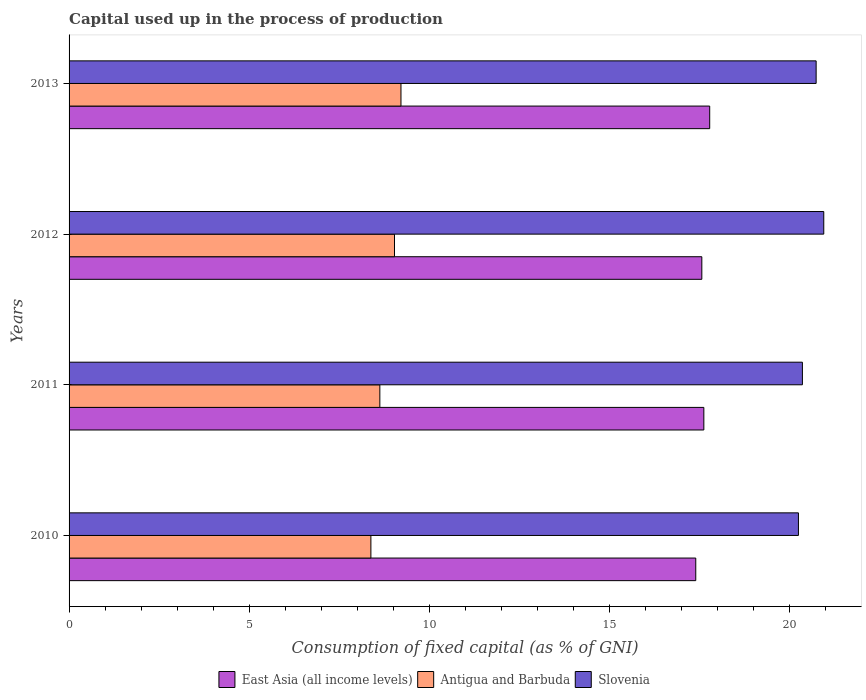How many groups of bars are there?
Provide a short and direct response. 4. How many bars are there on the 2nd tick from the top?
Give a very brief answer. 3. How many bars are there on the 4th tick from the bottom?
Keep it short and to the point. 3. In how many cases, is the number of bars for a given year not equal to the number of legend labels?
Offer a terse response. 0. What is the capital used up in the process of production in East Asia (all income levels) in 2010?
Keep it short and to the point. 17.4. Across all years, what is the maximum capital used up in the process of production in East Asia (all income levels)?
Your answer should be very brief. 17.78. Across all years, what is the minimum capital used up in the process of production in Antigua and Barbuda?
Give a very brief answer. 8.38. What is the total capital used up in the process of production in Antigua and Barbuda in the graph?
Provide a short and direct response. 35.25. What is the difference between the capital used up in the process of production in East Asia (all income levels) in 2010 and that in 2012?
Keep it short and to the point. -0.17. What is the difference between the capital used up in the process of production in Antigua and Barbuda in 2010 and the capital used up in the process of production in Slovenia in 2012?
Your answer should be compact. -12.57. What is the average capital used up in the process of production in Slovenia per year?
Your response must be concise. 20.57. In the year 2012, what is the difference between the capital used up in the process of production in Antigua and Barbuda and capital used up in the process of production in East Asia (all income levels)?
Offer a very short reply. -8.53. What is the ratio of the capital used up in the process of production in Slovenia in 2011 to that in 2012?
Offer a very short reply. 0.97. What is the difference between the highest and the second highest capital used up in the process of production in East Asia (all income levels)?
Provide a succinct answer. 0.16. What is the difference between the highest and the lowest capital used up in the process of production in Antigua and Barbuda?
Keep it short and to the point. 0.83. In how many years, is the capital used up in the process of production in East Asia (all income levels) greater than the average capital used up in the process of production in East Asia (all income levels) taken over all years?
Your response must be concise. 2. What does the 1st bar from the top in 2010 represents?
Give a very brief answer. Slovenia. What does the 3rd bar from the bottom in 2012 represents?
Provide a succinct answer. Slovenia. Are all the bars in the graph horizontal?
Your answer should be compact. Yes. How many years are there in the graph?
Offer a terse response. 4. Does the graph contain any zero values?
Provide a short and direct response. No. Where does the legend appear in the graph?
Provide a succinct answer. Bottom center. How are the legend labels stacked?
Make the answer very short. Horizontal. What is the title of the graph?
Give a very brief answer. Capital used up in the process of production. What is the label or title of the X-axis?
Offer a very short reply. Consumption of fixed capital (as % of GNI). What is the Consumption of fixed capital (as % of GNI) of East Asia (all income levels) in 2010?
Your answer should be very brief. 17.4. What is the Consumption of fixed capital (as % of GNI) in Antigua and Barbuda in 2010?
Your answer should be compact. 8.38. What is the Consumption of fixed capital (as % of GNI) of Slovenia in 2010?
Your response must be concise. 20.25. What is the Consumption of fixed capital (as % of GNI) of East Asia (all income levels) in 2011?
Ensure brevity in your answer.  17.62. What is the Consumption of fixed capital (as % of GNI) of Antigua and Barbuda in 2011?
Your response must be concise. 8.63. What is the Consumption of fixed capital (as % of GNI) in Slovenia in 2011?
Offer a very short reply. 20.36. What is the Consumption of fixed capital (as % of GNI) of East Asia (all income levels) in 2012?
Make the answer very short. 17.57. What is the Consumption of fixed capital (as % of GNI) of Antigua and Barbuda in 2012?
Provide a succinct answer. 9.03. What is the Consumption of fixed capital (as % of GNI) of Slovenia in 2012?
Provide a succinct answer. 20.95. What is the Consumption of fixed capital (as % of GNI) in East Asia (all income levels) in 2013?
Your answer should be compact. 17.78. What is the Consumption of fixed capital (as % of GNI) of Antigua and Barbuda in 2013?
Provide a short and direct response. 9.21. What is the Consumption of fixed capital (as % of GNI) in Slovenia in 2013?
Provide a succinct answer. 20.74. Across all years, what is the maximum Consumption of fixed capital (as % of GNI) in East Asia (all income levels)?
Offer a terse response. 17.78. Across all years, what is the maximum Consumption of fixed capital (as % of GNI) in Antigua and Barbuda?
Your answer should be compact. 9.21. Across all years, what is the maximum Consumption of fixed capital (as % of GNI) in Slovenia?
Ensure brevity in your answer.  20.95. Across all years, what is the minimum Consumption of fixed capital (as % of GNI) in East Asia (all income levels)?
Provide a succinct answer. 17.4. Across all years, what is the minimum Consumption of fixed capital (as % of GNI) in Antigua and Barbuda?
Offer a terse response. 8.38. Across all years, what is the minimum Consumption of fixed capital (as % of GNI) in Slovenia?
Keep it short and to the point. 20.25. What is the total Consumption of fixed capital (as % of GNI) in East Asia (all income levels) in the graph?
Give a very brief answer. 70.37. What is the total Consumption of fixed capital (as % of GNI) in Antigua and Barbuda in the graph?
Offer a terse response. 35.25. What is the total Consumption of fixed capital (as % of GNI) in Slovenia in the graph?
Ensure brevity in your answer.  82.3. What is the difference between the Consumption of fixed capital (as % of GNI) in East Asia (all income levels) in 2010 and that in 2011?
Your answer should be compact. -0.22. What is the difference between the Consumption of fixed capital (as % of GNI) of Antigua and Barbuda in 2010 and that in 2011?
Your response must be concise. -0.25. What is the difference between the Consumption of fixed capital (as % of GNI) in Slovenia in 2010 and that in 2011?
Make the answer very short. -0.11. What is the difference between the Consumption of fixed capital (as % of GNI) in East Asia (all income levels) in 2010 and that in 2012?
Make the answer very short. -0.17. What is the difference between the Consumption of fixed capital (as % of GNI) of Antigua and Barbuda in 2010 and that in 2012?
Offer a very short reply. -0.66. What is the difference between the Consumption of fixed capital (as % of GNI) in Slovenia in 2010 and that in 2012?
Give a very brief answer. -0.7. What is the difference between the Consumption of fixed capital (as % of GNI) of East Asia (all income levels) in 2010 and that in 2013?
Provide a succinct answer. -0.39. What is the difference between the Consumption of fixed capital (as % of GNI) of Antigua and Barbuda in 2010 and that in 2013?
Keep it short and to the point. -0.83. What is the difference between the Consumption of fixed capital (as % of GNI) of Slovenia in 2010 and that in 2013?
Provide a short and direct response. -0.49. What is the difference between the Consumption of fixed capital (as % of GNI) in East Asia (all income levels) in 2011 and that in 2012?
Provide a short and direct response. 0.06. What is the difference between the Consumption of fixed capital (as % of GNI) of Antigua and Barbuda in 2011 and that in 2012?
Keep it short and to the point. -0.41. What is the difference between the Consumption of fixed capital (as % of GNI) of Slovenia in 2011 and that in 2012?
Offer a very short reply. -0.59. What is the difference between the Consumption of fixed capital (as % of GNI) in East Asia (all income levels) in 2011 and that in 2013?
Make the answer very short. -0.16. What is the difference between the Consumption of fixed capital (as % of GNI) in Antigua and Barbuda in 2011 and that in 2013?
Make the answer very short. -0.59. What is the difference between the Consumption of fixed capital (as % of GNI) in Slovenia in 2011 and that in 2013?
Make the answer very short. -0.38. What is the difference between the Consumption of fixed capital (as % of GNI) of East Asia (all income levels) in 2012 and that in 2013?
Your answer should be compact. -0.22. What is the difference between the Consumption of fixed capital (as % of GNI) in Antigua and Barbuda in 2012 and that in 2013?
Provide a succinct answer. -0.18. What is the difference between the Consumption of fixed capital (as % of GNI) of Slovenia in 2012 and that in 2013?
Your answer should be compact. 0.21. What is the difference between the Consumption of fixed capital (as % of GNI) of East Asia (all income levels) in 2010 and the Consumption of fixed capital (as % of GNI) of Antigua and Barbuda in 2011?
Your answer should be compact. 8.77. What is the difference between the Consumption of fixed capital (as % of GNI) of East Asia (all income levels) in 2010 and the Consumption of fixed capital (as % of GNI) of Slovenia in 2011?
Provide a succinct answer. -2.96. What is the difference between the Consumption of fixed capital (as % of GNI) of Antigua and Barbuda in 2010 and the Consumption of fixed capital (as % of GNI) of Slovenia in 2011?
Provide a succinct answer. -11.98. What is the difference between the Consumption of fixed capital (as % of GNI) in East Asia (all income levels) in 2010 and the Consumption of fixed capital (as % of GNI) in Antigua and Barbuda in 2012?
Offer a terse response. 8.36. What is the difference between the Consumption of fixed capital (as % of GNI) in East Asia (all income levels) in 2010 and the Consumption of fixed capital (as % of GNI) in Slovenia in 2012?
Offer a terse response. -3.55. What is the difference between the Consumption of fixed capital (as % of GNI) of Antigua and Barbuda in 2010 and the Consumption of fixed capital (as % of GNI) of Slovenia in 2012?
Offer a terse response. -12.57. What is the difference between the Consumption of fixed capital (as % of GNI) in East Asia (all income levels) in 2010 and the Consumption of fixed capital (as % of GNI) in Antigua and Barbuda in 2013?
Keep it short and to the point. 8.18. What is the difference between the Consumption of fixed capital (as % of GNI) in East Asia (all income levels) in 2010 and the Consumption of fixed capital (as % of GNI) in Slovenia in 2013?
Give a very brief answer. -3.34. What is the difference between the Consumption of fixed capital (as % of GNI) of Antigua and Barbuda in 2010 and the Consumption of fixed capital (as % of GNI) of Slovenia in 2013?
Offer a terse response. -12.36. What is the difference between the Consumption of fixed capital (as % of GNI) in East Asia (all income levels) in 2011 and the Consumption of fixed capital (as % of GNI) in Antigua and Barbuda in 2012?
Your answer should be very brief. 8.59. What is the difference between the Consumption of fixed capital (as % of GNI) in East Asia (all income levels) in 2011 and the Consumption of fixed capital (as % of GNI) in Slovenia in 2012?
Ensure brevity in your answer.  -3.33. What is the difference between the Consumption of fixed capital (as % of GNI) of Antigua and Barbuda in 2011 and the Consumption of fixed capital (as % of GNI) of Slovenia in 2012?
Provide a succinct answer. -12.32. What is the difference between the Consumption of fixed capital (as % of GNI) in East Asia (all income levels) in 2011 and the Consumption of fixed capital (as % of GNI) in Antigua and Barbuda in 2013?
Give a very brief answer. 8.41. What is the difference between the Consumption of fixed capital (as % of GNI) in East Asia (all income levels) in 2011 and the Consumption of fixed capital (as % of GNI) in Slovenia in 2013?
Make the answer very short. -3.12. What is the difference between the Consumption of fixed capital (as % of GNI) of Antigua and Barbuda in 2011 and the Consumption of fixed capital (as % of GNI) of Slovenia in 2013?
Your response must be concise. -12.11. What is the difference between the Consumption of fixed capital (as % of GNI) of East Asia (all income levels) in 2012 and the Consumption of fixed capital (as % of GNI) of Antigua and Barbuda in 2013?
Your answer should be compact. 8.35. What is the difference between the Consumption of fixed capital (as % of GNI) of East Asia (all income levels) in 2012 and the Consumption of fixed capital (as % of GNI) of Slovenia in 2013?
Ensure brevity in your answer.  -3.17. What is the difference between the Consumption of fixed capital (as % of GNI) of Antigua and Barbuda in 2012 and the Consumption of fixed capital (as % of GNI) of Slovenia in 2013?
Give a very brief answer. -11.71. What is the average Consumption of fixed capital (as % of GNI) in East Asia (all income levels) per year?
Keep it short and to the point. 17.59. What is the average Consumption of fixed capital (as % of GNI) in Antigua and Barbuda per year?
Your response must be concise. 8.81. What is the average Consumption of fixed capital (as % of GNI) in Slovenia per year?
Keep it short and to the point. 20.57. In the year 2010, what is the difference between the Consumption of fixed capital (as % of GNI) in East Asia (all income levels) and Consumption of fixed capital (as % of GNI) in Antigua and Barbuda?
Ensure brevity in your answer.  9.02. In the year 2010, what is the difference between the Consumption of fixed capital (as % of GNI) of East Asia (all income levels) and Consumption of fixed capital (as % of GNI) of Slovenia?
Give a very brief answer. -2.85. In the year 2010, what is the difference between the Consumption of fixed capital (as % of GNI) in Antigua and Barbuda and Consumption of fixed capital (as % of GNI) in Slovenia?
Make the answer very short. -11.87. In the year 2011, what is the difference between the Consumption of fixed capital (as % of GNI) of East Asia (all income levels) and Consumption of fixed capital (as % of GNI) of Antigua and Barbuda?
Offer a terse response. 8.99. In the year 2011, what is the difference between the Consumption of fixed capital (as % of GNI) in East Asia (all income levels) and Consumption of fixed capital (as % of GNI) in Slovenia?
Your answer should be very brief. -2.74. In the year 2011, what is the difference between the Consumption of fixed capital (as % of GNI) of Antigua and Barbuda and Consumption of fixed capital (as % of GNI) of Slovenia?
Your response must be concise. -11.73. In the year 2012, what is the difference between the Consumption of fixed capital (as % of GNI) of East Asia (all income levels) and Consumption of fixed capital (as % of GNI) of Antigua and Barbuda?
Your response must be concise. 8.53. In the year 2012, what is the difference between the Consumption of fixed capital (as % of GNI) in East Asia (all income levels) and Consumption of fixed capital (as % of GNI) in Slovenia?
Your response must be concise. -3.38. In the year 2012, what is the difference between the Consumption of fixed capital (as % of GNI) of Antigua and Barbuda and Consumption of fixed capital (as % of GNI) of Slovenia?
Make the answer very short. -11.92. In the year 2013, what is the difference between the Consumption of fixed capital (as % of GNI) in East Asia (all income levels) and Consumption of fixed capital (as % of GNI) in Antigua and Barbuda?
Keep it short and to the point. 8.57. In the year 2013, what is the difference between the Consumption of fixed capital (as % of GNI) of East Asia (all income levels) and Consumption of fixed capital (as % of GNI) of Slovenia?
Your response must be concise. -2.95. In the year 2013, what is the difference between the Consumption of fixed capital (as % of GNI) of Antigua and Barbuda and Consumption of fixed capital (as % of GNI) of Slovenia?
Provide a succinct answer. -11.53. What is the ratio of the Consumption of fixed capital (as % of GNI) in East Asia (all income levels) in 2010 to that in 2011?
Your answer should be very brief. 0.99. What is the ratio of the Consumption of fixed capital (as % of GNI) in Antigua and Barbuda in 2010 to that in 2011?
Your answer should be very brief. 0.97. What is the ratio of the Consumption of fixed capital (as % of GNI) in Antigua and Barbuda in 2010 to that in 2012?
Provide a short and direct response. 0.93. What is the ratio of the Consumption of fixed capital (as % of GNI) of Slovenia in 2010 to that in 2012?
Provide a succinct answer. 0.97. What is the ratio of the Consumption of fixed capital (as % of GNI) in East Asia (all income levels) in 2010 to that in 2013?
Give a very brief answer. 0.98. What is the ratio of the Consumption of fixed capital (as % of GNI) in Antigua and Barbuda in 2010 to that in 2013?
Your response must be concise. 0.91. What is the ratio of the Consumption of fixed capital (as % of GNI) in Slovenia in 2010 to that in 2013?
Ensure brevity in your answer.  0.98. What is the ratio of the Consumption of fixed capital (as % of GNI) of East Asia (all income levels) in 2011 to that in 2012?
Provide a succinct answer. 1. What is the ratio of the Consumption of fixed capital (as % of GNI) in Antigua and Barbuda in 2011 to that in 2012?
Offer a very short reply. 0.95. What is the ratio of the Consumption of fixed capital (as % of GNI) in Slovenia in 2011 to that in 2012?
Make the answer very short. 0.97. What is the ratio of the Consumption of fixed capital (as % of GNI) of East Asia (all income levels) in 2011 to that in 2013?
Give a very brief answer. 0.99. What is the ratio of the Consumption of fixed capital (as % of GNI) of Antigua and Barbuda in 2011 to that in 2013?
Your response must be concise. 0.94. What is the ratio of the Consumption of fixed capital (as % of GNI) in Slovenia in 2011 to that in 2013?
Ensure brevity in your answer.  0.98. What is the ratio of the Consumption of fixed capital (as % of GNI) in East Asia (all income levels) in 2012 to that in 2013?
Offer a very short reply. 0.99. What is the ratio of the Consumption of fixed capital (as % of GNI) in Antigua and Barbuda in 2012 to that in 2013?
Provide a succinct answer. 0.98. What is the ratio of the Consumption of fixed capital (as % of GNI) in Slovenia in 2012 to that in 2013?
Your answer should be very brief. 1.01. What is the difference between the highest and the second highest Consumption of fixed capital (as % of GNI) of East Asia (all income levels)?
Your answer should be compact. 0.16. What is the difference between the highest and the second highest Consumption of fixed capital (as % of GNI) in Antigua and Barbuda?
Offer a terse response. 0.18. What is the difference between the highest and the second highest Consumption of fixed capital (as % of GNI) of Slovenia?
Provide a short and direct response. 0.21. What is the difference between the highest and the lowest Consumption of fixed capital (as % of GNI) of East Asia (all income levels)?
Offer a very short reply. 0.39. What is the difference between the highest and the lowest Consumption of fixed capital (as % of GNI) of Antigua and Barbuda?
Your answer should be compact. 0.83. What is the difference between the highest and the lowest Consumption of fixed capital (as % of GNI) in Slovenia?
Your answer should be very brief. 0.7. 